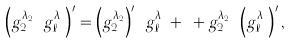Convert formula to latex. <formula><loc_0><loc_0><loc_500><loc_500>\left ( g _ { 2 } ^ { \lambda _ { 2 } } \cdots g _ { \ell } ^ { \lambda _ { \ell } } \right ) ^ { \prime } = \left ( g _ { 2 } ^ { \lambda _ { 2 } } \right ) ^ { \prime } \cdots g _ { \ell } ^ { \lambda _ { \ell } } + \cdots + g _ { 2 } ^ { \lambda _ { 2 } } \cdots \left ( g _ { \ell } ^ { \lambda _ { \ell } } \right ) ^ { \prime } ,</formula> 